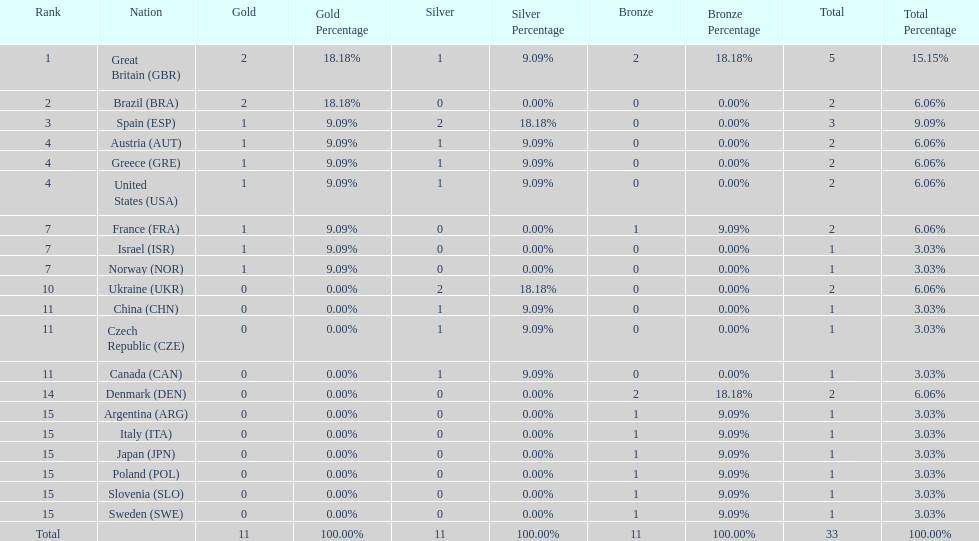What country had the most medals? Great Britain. 